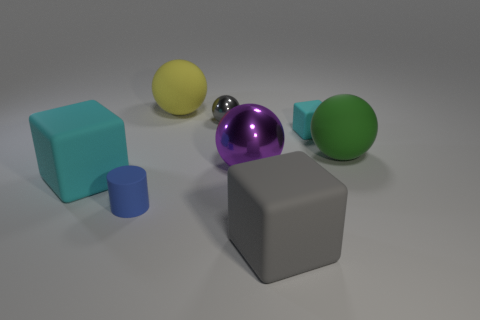Is there a small rubber block that is in front of the big rubber block that is left of the large yellow matte sphere?
Your response must be concise. No. What number of objects are purple metallic spheres or green balls?
Ensure brevity in your answer.  2. The matte thing that is on the right side of the cyan rubber object that is on the right side of the rubber cube on the left side of the big gray matte object is what color?
Provide a succinct answer. Green. Is there anything else of the same color as the cylinder?
Offer a terse response. No. Is the size of the green ball the same as the gray rubber object?
Provide a succinct answer. Yes. What number of things are large matte balls that are behind the green matte object or balls that are in front of the small shiny thing?
Offer a very short reply. 3. The cyan thing behind the matte object to the left of the small blue thing is made of what material?
Offer a very short reply. Rubber. What number of other objects are there of the same material as the small cyan block?
Your answer should be very brief. 5. Is the shape of the gray shiny thing the same as the yellow rubber thing?
Your answer should be compact. Yes. How big is the metallic ball that is behind the big green ball?
Provide a succinct answer. Small. 